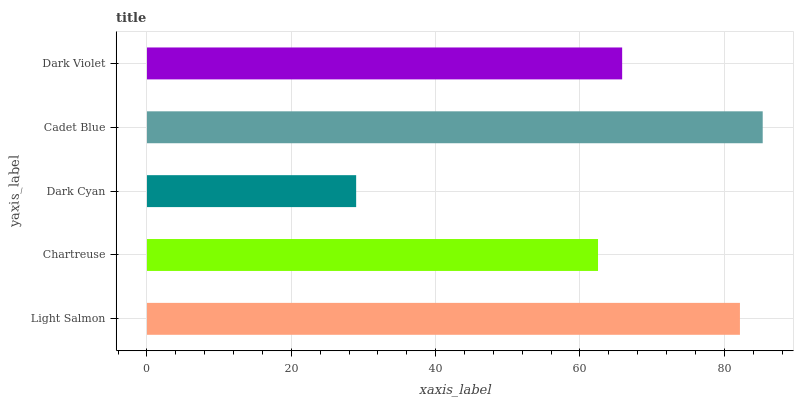Is Dark Cyan the minimum?
Answer yes or no. Yes. Is Cadet Blue the maximum?
Answer yes or no. Yes. Is Chartreuse the minimum?
Answer yes or no. No. Is Chartreuse the maximum?
Answer yes or no. No. Is Light Salmon greater than Chartreuse?
Answer yes or no. Yes. Is Chartreuse less than Light Salmon?
Answer yes or no. Yes. Is Chartreuse greater than Light Salmon?
Answer yes or no. No. Is Light Salmon less than Chartreuse?
Answer yes or no. No. Is Dark Violet the high median?
Answer yes or no. Yes. Is Dark Violet the low median?
Answer yes or no. Yes. Is Chartreuse the high median?
Answer yes or no. No. Is Cadet Blue the low median?
Answer yes or no. No. 